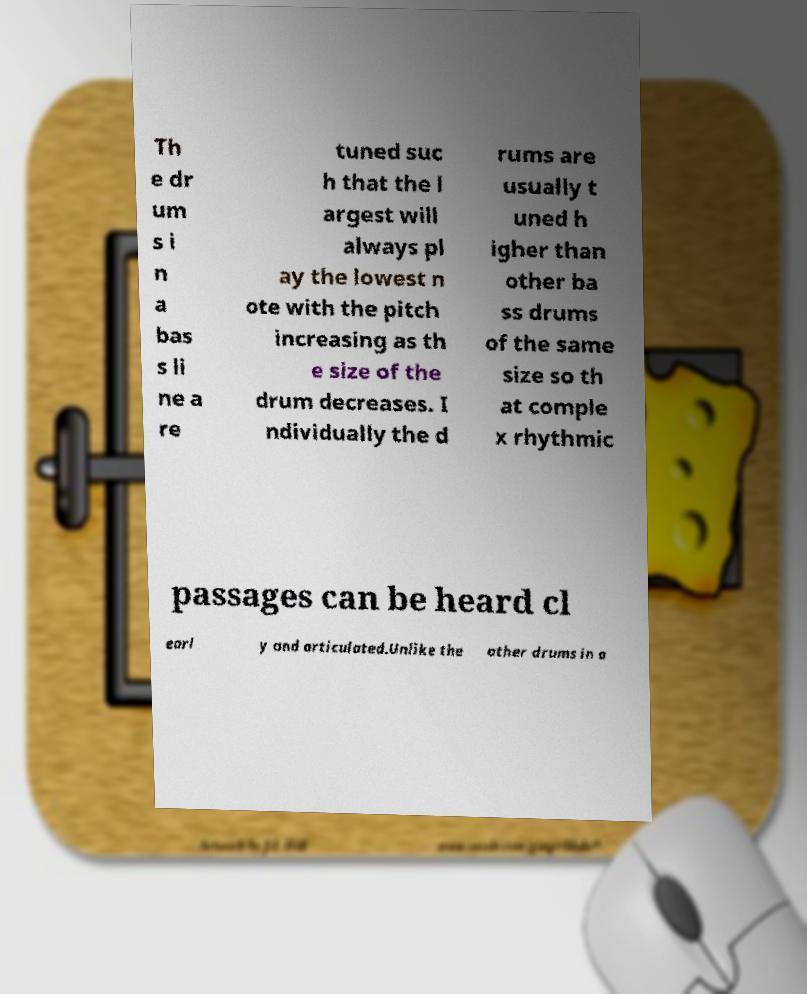Please identify and transcribe the text found in this image. Th e dr um s i n a bas s li ne a re tuned suc h that the l argest will always pl ay the lowest n ote with the pitch increasing as th e size of the drum decreases. I ndividually the d rums are usually t uned h igher than other ba ss drums of the same size so th at comple x rhythmic passages can be heard cl earl y and articulated.Unlike the other drums in a 